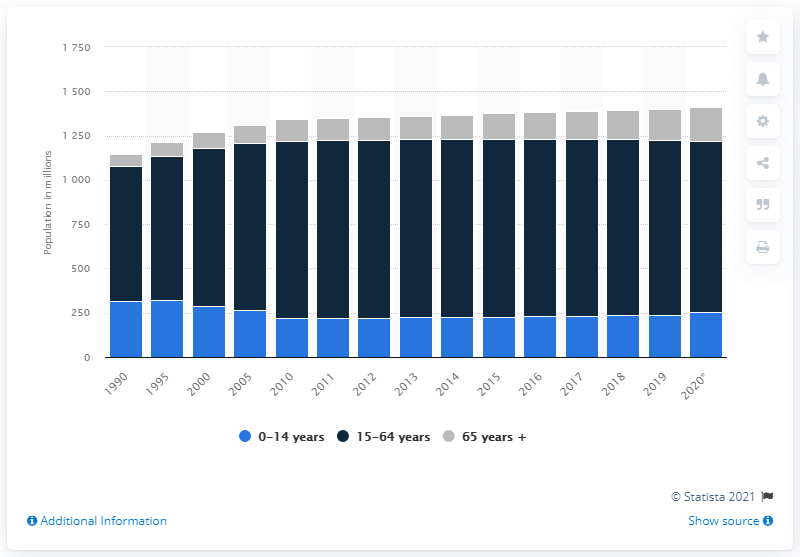Highlight a few significant elements in this photo. In 2020, there were approximately 967.76 people aged between 15 and 64. 